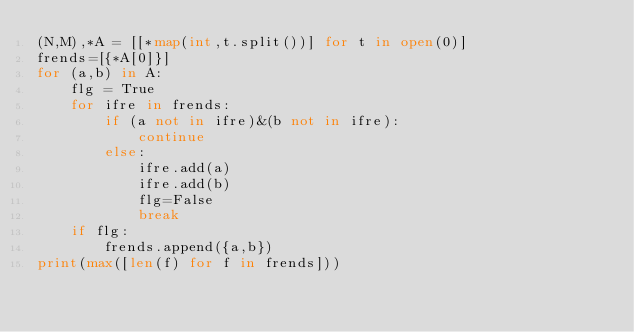<code> <loc_0><loc_0><loc_500><loc_500><_Python_>(N,M),*A = [[*map(int,t.split())] for t in open(0)]
frends=[{*A[0]}]
for (a,b) in A:
    flg = True
    for ifre in frends:
        if (a not in ifre)&(b not in ifre):
            continue
        else:
            ifre.add(a)
            ifre.add(b)
            flg=False
            break
    if flg:
        frends.append({a,b})
print(max([len(f) for f in frends]))</code> 